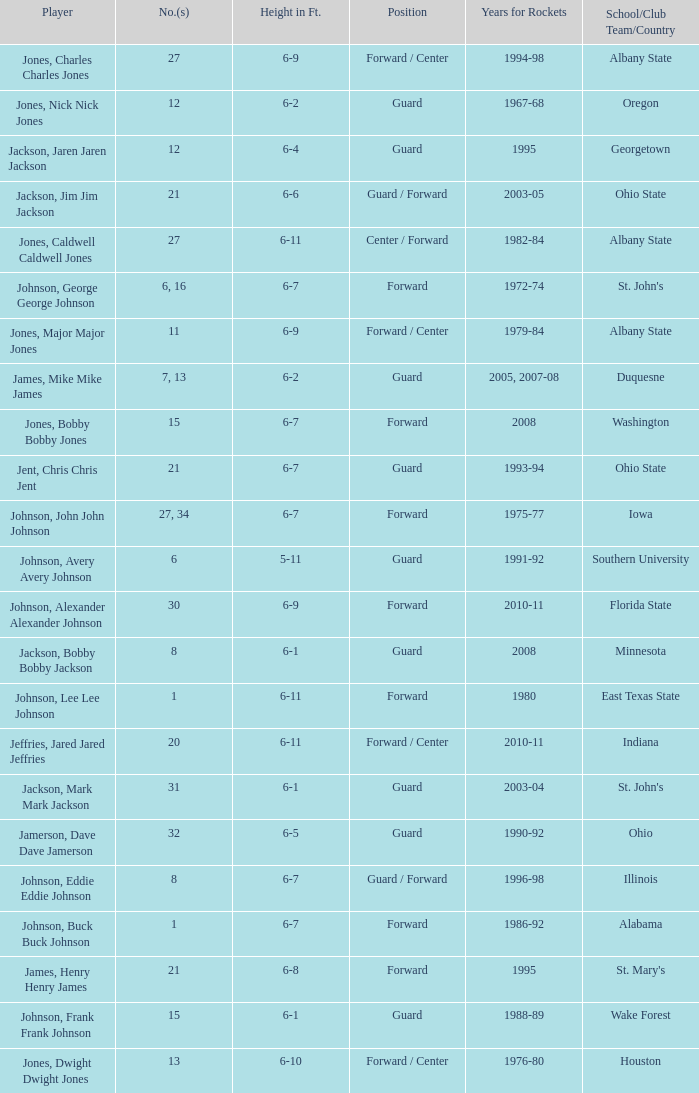Which player who played for the Rockets for the years 1986-92? Johnson, Buck Buck Johnson. 